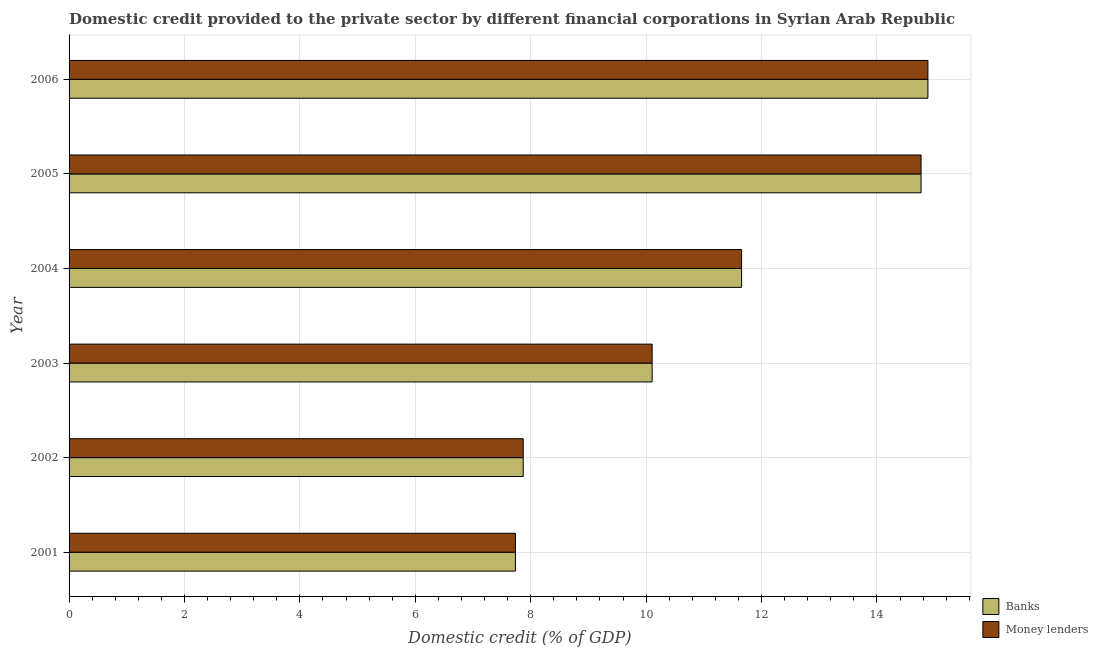How many different coloured bars are there?
Make the answer very short. 2. How many groups of bars are there?
Your response must be concise. 6. Are the number of bars on each tick of the Y-axis equal?
Provide a succinct answer. Yes. How many bars are there on the 5th tick from the bottom?
Make the answer very short. 2. In how many cases, is the number of bars for a given year not equal to the number of legend labels?
Offer a terse response. 0. What is the domestic credit provided by banks in 2001?
Ensure brevity in your answer.  7.74. Across all years, what is the maximum domestic credit provided by banks?
Make the answer very short. 14.88. Across all years, what is the minimum domestic credit provided by banks?
Your answer should be compact. 7.74. In which year was the domestic credit provided by banks maximum?
Keep it short and to the point. 2006. What is the total domestic credit provided by money lenders in the graph?
Provide a short and direct response. 67.01. What is the difference between the domestic credit provided by money lenders in 2001 and that in 2002?
Keep it short and to the point. -0.14. What is the difference between the domestic credit provided by banks in 2001 and the domestic credit provided by money lenders in 2006?
Your answer should be very brief. -7.15. What is the average domestic credit provided by money lenders per year?
Ensure brevity in your answer.  11.17. In the year 2006, what is the difference between the domestic credit provided by banks and domestic credit provided by money lenders?
Offer a terse response. 0. What is the ratio of the domestic credit provided by money lenders in 2001 to that in 2004?
Give a very brief answer. 0.66. What is the difference between the highest and the second highest domestic credit provided by banks?
Make the answer very short. 0.12. What is the difference between the highest and the lowest domestic credit provided by money lenders?
Your answer should be compact. 7.15. Is the sum of the domestic credit provided by banks in 2004 and 2005 greater than the maximum domestic credit provided by money lenders across all years?
Your response must be concise. Yes. What does the 1st bar from the top in 2001 represents?
Your answer should be very brief. Money lenders. What does the 2nd bar from the bottom in 2003 represents?
Ensure brevity in your answer.  Money lenders. How many bars are there?
Provide a short and direct response. 12. Are all the bars in the graph horizontal?
Your answer should be very brief. Yes. What is the difference between two consecutive major ticks on the X-axis?
Provide a short and direct response. 2. Does the graph contain any zero values?
Your answer should be compact. No. Does the graph contain grids?
Provide a succinct answer. Yes. How many legend labels are there?
Your answer should be very brief. 2. What is the title of the graph?
Give a very brief answer. Domestic credit provided to the private sector by different financial corporations in Syrian Arab Republic. What is the label or title of the X-axis?
Give a very brief answer. Domestic credit (% of GDP). What is the label or title of the Y-axis?
Provide a succinct answer. Year. What is the Domestic credit (% of GDP) in Banks in 2001?
Your answer should be very brief. 7.74. What is the Domestic credit (% of GDP) in Money lenders in 2001?
Keep it short and to the point. 7.74. What is the Domestic credit (% of GDP) in Banks in 2002?
Your answer should be compact. 7.87. What is the Domestic credit (% of GDP) of Money lenders in 2002?
Ensure brevity in your answer.  7.87. What is the Domestic credit (% of GDP) in Banks in 2003?
Offer a very short reply. 10.1. What is the Domestic credit (% of GDP) of Money lenders in 2003?
Your answer should be compact. 10.1. What is the Domestic credit (% of GDP) of Banks in 2004?
Give a very brief answer. 11.65. What is the Domestic credit (% of GDP) of Money lenders in 2004?
Provide a short and direct response. 11.65. What is the Domestic credit (% of GDP) in Banks in 2005?
Give a very brief answer. 14.76. What is the Domestic credit (% of GDP) in Money lenders in 2005?
Offer a very short reply. 14.76. What is the Domestic credit (% of GDP) of Banks in 2006?
Make the answer very short. 14.88. What is the Domestic credit (% of GDP) of Money lenders in 2006?
Give a very brief answer. 14.88. Across all years, what is the maximum Domestic credit (% of GDP) of Banks?
Your answer should be very brief. 14.88. Across all years, what is the maximum Domestic credit (% of GDP) in Money lenders?
Your answer should be compact. 14.88. Across all years, what is the minimum Domestic credit (% of GDP) of Banks?
Provide a succinct answer. 7.74. Across all years, what is the minimum Domestic credit (% of GDP) in Money lenders?
Make the answer very short. 7.74. What is the total Domestic credit (% of GDP) in Banks in the graph?
Keep it short and to the point. 67.01. What is the total Domestic credit (% of GDP) of Money lenders in the graph?
Give a very brief answer. 67.01. What is the difference between the Domestic credit (% of GDP) in Banks in 2001 and that in 2002?
Offer a terse response. -0.14. What is the difference between the Domestic credit (% of GDP) in Money lenders in 2001 and that in 2002?
Your answer should be very brief. -0.14. What is the difference between the Domestic credit (% of GDP) of Banks in 2001 and that in 2003?
Offer a very short reply. -2.37. What is the difference between the Domestic credit (% of GDP) of Money lenders in 2001 and that in 2003?
Ensure brevity in your answer.  -2.37. What is the difference between the Domestic credit (% of GDP) in Banks in 2001 and that in 2004?
Offer a very short reply. -3.92. What is the difference between the Domestic credit (% of GDP) of Money lenders in 2001 and that in 2004?
Provide a short and direct response. -3.92. What is the difference between the Domestic credit (% of GDP) in Banks in 2001 and that in 2005?
Your answer should be compact. -7.03. What is the difference between the Domestic credit (% of GDP) of Money lenders in 2001 and that in 2005?
Provide a short and direct response. -7.03. What is the difference between the Domestic credit (% of GDP) of Banks in 2001 and that in 2006?
Make the answer very short. -7.15. What is the difference between the Domestic credit (% of GDP) of Money lenders in 2001 and that in 2006?
Keep it short and to the point. -7.15. What is the difference between the Domestic credit (% of GDP) of Banks in 2002 and that in 2003?
Provide a short and direct response. -2.23. What is the difference between the Domestic credit (% of GDP) of Money lenders in 2002 and that in 2003?
Your answer should be compact. -2.23. What is the difference between the Domestic credit (% of GDP) of Banks in 2002 and that in 2004?
Offer a very short reply. -3.78. What is the difference between the Domestic credit (% of GDP) in Money lenders in 2002 and that in 2004?
Your answer should be very brief. -3.78. What is the difference between the Domestic credit (% of GDP) of Banks in 2002 and that in 2005?
Ensure brevity in your answer.  -6.89. What is the difference between the Domestic credit (% of GDP) in Money lenders in 2002 and that in 2005?
Your answer should be compact. -6.89. What is the difference between the Domestic credit (% of GDP) in Banks in 2002 and that in 2006?
Give a very brief answer. -7.01. What is the difference between the Domestic credit (% of GDP) of Money lenders in 2002 and that in 2006?
Provide a short and direct response. -7.01. What is the difference between the Domestic credit (% of GDP) of Banks in 2003 and that in 2004?
Offer a very short reply. -1.55. What is the difference between the Domestic credit (% of GDP) of Money lenders in 2003 and that in 2004?
Your answer should be very brief. -1.55. What is the difference between the Domestic credit (% of GDP) of Banks in 2003 and that in 2005?
Ensure brevity in your answer.  -4.66. What is the difference between the Domestic credit (% of GDP) in Money lenders in 2003 and that in 2005?
Your answer should be very brief. -4.66. What is the difference between the Domestic credit (% of GDP) of Banks in 2003 and that in 2006?
Ensure brevity in your answer.  -4.78. What is the difference between the Domestic credit (% of GDP) in Money lenders in 2003 and that in 2006?
Keep it short and to the point. -4.78. What is the difference between the Domestic credit (% of GDP) of Banks in 2004 and that in 2005?
Provide a succinct answer. -3.11. What is the difference between the Domestic credit (% of GDP) of Money lenders in 2004 and that in 2005?
Ensure brevity in your answer.  -3.11. What is the difference between the Domestic credit (% of GDP) of Banks in 2004 and that in 2006?
Give a very brief answer. -3.23. What is the difference between the Domestic credit (% of GDP) in Money lenders in 2004 and that in 2006?
Make the answer very short. -3.23. What is the difference between the Domestic credit (% of GDP) of Banks in 2005 and that in 2006?
Provide a succinct answer. -0.12. What is the difference between the Domestic credit (% of GDP) of Money lenders in 2005 and that in 2006?
Keep it short and to the point. -0.12. What is the difference between the Domestic credit (% of GDP) of Banks in 2001 and the Domestic credit (% of GDP) of Money lenders in 2002?
Your response must be concise. -0.14. What is the difference between the Domestic credit (% of GDP) in Banks in 2001 and the Domestic credit (% of GDP) in Money lenders in 2003?
Your response must be concise. -2.37. What is the difference between the Domestic credit (% of GDP) of Banks in 2001 and the Domestic credit (% of GDP) of Money lenders in 2004?
Make the answer very short. -3.92. What is the difference between the Domestic credit (% of GDP) of Banks in 2001 and the Domestic credit (% of GDP) of Money lenders in 2005?
Your answer should be compact. -7.03. What is the difference between the Domestic credit (% of GDP) in Banks in 2001 and the Domestic credit (% of GDP) in Money lenders in 2006?
Offer a terse response. -7.15. What is the difference between the Domestic credit (% of GDP) of Banks in 2002 and the Domestic credit (% of GDP) of Money lenders in 2003?
Provide a succinct answer. -2.23. What is the difference between the Domestic credit (% of GDP) of Banks in 2002 and the Domestic credit (% of GDP) of Money lenders in 2004?
Your response must be concise. -3.78. What is the difference between the Domestic credit (% of GDP) of Banks in 2002 and the Domestic credit (% of GDP) of Money lenders in 2005?
Offer a very short reply. -6.89. What is the difference between the Domestic credit (% of GDP) in Banks in 2002 and the Domestic credit (% of GDP) in Money lenders in 2006?
Your response must be concise. -7.01. What is the difference between the Domestic credit (% of GDP) in Banks in 2003 and the Domestic credit (% of GDP) in Money lenders in 2004?
Provide a succinct answer. -1.55. What is the difference between the Domestic credit (% of GDP) in Banks in 2003 and the Domestic credit (% of GDP) in Money lenders in 2005?
Your answer should be very brief. -4.66. What is the difference between the Domestic credit (% of GDP) of Banks in 2003 and the Domestic credit (% of GDP) of Money lenders in 2006?
Your response must be concise. -4.78. What is the difference between the Domestic credit (% of GDP) of Banks in 2004 and the Domestic credit (% of GDP) of Money lenders in 2005?
Provide a succinct answer. -3.11. What is the difference between the Domestic credit (% of GDP) of Banks in 2004 and the Domestic credit (% of GDP) of Money lenders in 2006?
Offer a terse response. -3.23. What is the difference between the Domestic credit (% of GDP) of Banks in 2005 and the Domestic credit (% of GDP) of Money lenders in 2006?
Provide a short and direct response. -0.12. What is the average Domestic credit (% of GDP) in Banks per year?
Your response must be concise. 11.17. What is the average Domestic credit (% of GDP) in Money lenders per year?
Ensure brevity in your answer.  11.17. In the year 2001, what is the difference between the Domestic credit (% of GDP) of Banks and Domestic credit (% of GDP) of Money lenders?
Your response must be concise. 0. In the year 2003, what is the difference between the Domestic credit (% of GDP) in Banks and Domestic credit (% of GDP) in Money lenders?
Offer a terse response. 0. In the year 2004, what is the difference between the Domestic credit (% of GDP) in Banks and Domestic credit (% of GDP) in Money lenders?
Offer a terse response. 0. In the year 2005, what is the difference between the Domestic credit (% of GDP) in Banks and Domestic credit (% of GDP) in Money lenders?
Ensure brevity in your answer.  0. What is the ratio of the Domestic credit (% of GDP) in Banks in 2001 to that in 2002?
Keep it short and to the point. 0.98. What is the ratio of the Domestic credit (% of GDP) of Money lenders in 2001 to that in 2002?
Ensure brevity in your answer.  0.98. What is the ratio of the Domestic credit (% of GDP) of Banks in 2001 to that in 2003?
Your answer should be very brief. 0.77. What is the ratio of the Domestic credit (% of GDP) of Money lenders in 2001 to that in 2003?
Your answer should be compact. 0.77. What is the ratio of the Domestic credit (% of GDP) of Banks in 2001 to that in 2004?
Offer a very short reply. 0.66. What is the ratio of the Domestic credit (% of GDP) in Money lenders in 2001 to that in 2004?
Offer a terse response. 0.66. What is the ratio of the Domestic credit (% of GDP) in Banks in 2001 to that in 2005?
Your answer should be compact. 0.52. What is the ratio of the Domestic credit (% of GDP) in Money lenders in 2001 to that in 2005?
Make the answer very short. 0.52. What is the ratio of the Domestic credit (% of GDP) in Banks in 2001 to that in 2006?
Your answer should be very brief. 0.52. What is the ratio of the Domestic credit (% of GDP) in Money lenders in 2001 to that in 2006?
Your answer should be very brief. 0.52. What is the ratio of the Domestic credit (% of GDP) of Banks in 2002 to that in 2003?
Give a very brief answer. 0.78. What is the ratio of the Domestic credit (% of GDP) in Money lenders in 2002 to that in 2003?
Your answer should be very brief. 0.78. What is the ratio of the Domestic credit (% of GDP) in Banks in 2002 to that in 2004?
Make the answer very short. 0.68. What is the ratio of the Domestic credit (% of GDP) of Money lenders in 2002 to that in 2004?
Provide a succinct answer. 0.68. What is the ratio of the Domestic credit (% of GDP) of Banks in 2002 to that in 2005?
Offer a terse response. 0.53. What is the ratio of the Domestic credit (% of GDP) of Money lenders in 2002 to that in 2005?
Ensure brevity in your answer.  0.53. What is the ratio of the Domestic credit (% of GDP) of Banks in 2002 to that in 2006?
Ensure brevity in your answer.  0.53. What is the ratio of the Domestic credit (% of GDP) in Money lenders in 2002 to that in 2006?
Your answer should be very brief. 0.53. What is the ratio of the Domestic credit (% of GDP) in Banks in 2003 to that in 2004?
Your response must be concise. 0.87. What is the ratio of the Domestic credit (% of GDP) in Money lenders in 2003 to that in 2004?
Your answer should be very brief. 0.87. What is the ratio of the Domestic credit (% of GDP) in Banks in 2003 to that in 2005?
Keep it short and to the point. 0.68. What is the ratio of the Domestic credit (% of GDP) in Money lenders in 2003 to that in 2005?
Provide a succinct answer. 0.68. What is the ratio of the Domestic credit (% of GDP) in Banks in 2003 to that in 2006?
Your response must be concise. 0.68. What is the ratio of the Domestic credit (% of GDP) in Money lenders in 2003 to that in 2006?
Offer a very short reply. 0.68. What is the ratio of the Domestic credit (% of GDP) in Banks in 2004 to that in 2005?
Your answer should be compact. 0.79. What is the ratio of the Domestic credit (% of GDP) of Money lenders in 2004 to that in 2005?
Provide a succinct answer. 0.79. What is the ratio of the Domestic credit (% of GDP) of Banks in 2004 to that in 2006?
Keep it short and to the point. 0.78. What is the ratio of the Domestic credit (% of GDP) of Money lenders in 2004 to that in 2006?
Offer a very short reply. 0.78. What is the ratio of the Domestic credit (% of GDP) of Banks in 2005 to that in 2006?
Give a very brief answer. 0.99. What is the ratio of the Domestic credit (% of GDP) in Money lenders in 2005 to that in 2006?
Provide a succinct answer. 0.99. What is the difference between the highest and the second highest Domestic credit (% of GDP) of Banks?
Your answer should be compact. 0.12. What is the difference between the highest and the second highest Domestic credit (% of GDP) in Money lenders?
Give a very brief answer. 0.12. What is the difference between the highest and the lowest Domestic credit (% of GDP) in Banks?
Your answer should be very brief. 7.15. What is the difference between the highest and the lowest Domestic credit (% of GDP) of Money lenders?
Your answer should be compact. 7.15. 